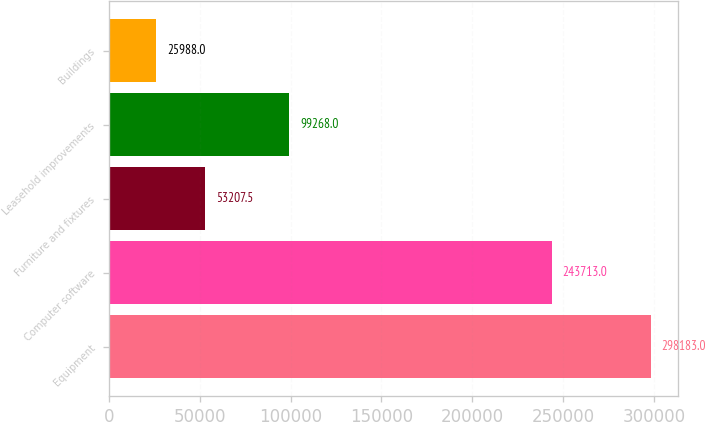Convert chart. <chart><loc_0><loc_0><loc_500><loc_500><bar_chart><fcel>Equipment<fcel>Computer software<fcel>Furniture and fixtures<fcel>Leasehold improvements<fcel>Buildings<nl><fcel>298183<fcel>243713<fcel>53207.5<fcel>99268<fcel>25988<nl></chart> 